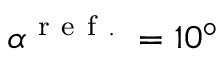<formula> <loc_0><loc_0><loc_500><loc_500>\alpha ^ { r e f . } = 1 0 ^ { \circ }</formula> 